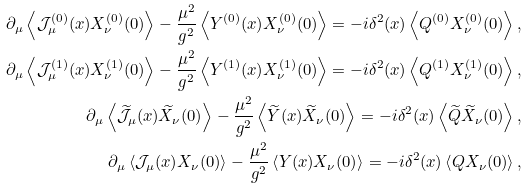Convert formula to latex. <formula><loc_0><loc_0><loc_500><loc_500>\partial _ { \mu } \left \langle \mathcal { J } _ { \mu } ^ { ( 0 ) } ( x ) X _ { \nu } ^ { ( 0 ) } ( 0 ) \right \rangle - \frac { \mu ^ { 2 } } { g ^ { 2 } } \left \langle Y ^ { ( 0 ) } ( x ) X _ { \nu } ^ { ( 0 ) } ( 0 ) \right \rangle = - i \delta ^ { 2 } ( x ) \left \langle Q ^ { ( 0 ) } X _ { \nu } ^ { ( 0 ) } ( 0 ) \right \rangle , \\ \partial _ { \mu } \left \langle \mathcal { J } _ { \mu } ^ { ( 1 ) } ( x ) X _ { \nu } ^ { ( 1 ) } ( 0 ) \right \rangle - \frac { \mu ^ { 2 } } { g ^ { 2 } } \left \langle Y ^ { ( 1 ) } ( x ) X _ { \nu } ^ { ( 1 ) } ( 0 ) \right \rangle = - i \delta ^ { 2 } ( x ) \left \langle Q ^ { ( 1 ) } X _ { \nu } ^ { ( 1 ) } ( 0 ) \right \rangle , \\ \partial _ { \mu } \left \langle \widetilde { \mathcal { J } } _ { \mu } ( x ) \widetilde { X } _ { \nu } ( 0 ) \right \rangle - \frac { \mu ^ { 2 } } { g ^ { 2 } } \left \langle \widetilde { Y } ( x ) \widetilde { X } _ { \nu } ( 0 ) \right \rangle = - i \delta ^ { 2 } ( x ) \left \langle \widetilde { Q } \widetilde { X } _ { \nu } ( 0 ) \right \rangle , \\ \partial _ { \mu } \left \langle \mathcal { J } _ { \mu } ( x ) X _ { \nu } ( 0 ) \right \rangle - \frac { \mu ^ { 2 } } { g ^ { 2 } } \left \langle Y ( x ) X _ { \nu } ( 0 ) \right \rangle = - i \delta ^ { 2 } ( x ) \left \langle Q X _ { \nu } ( 0 ) \right \rangle ,</formula> 